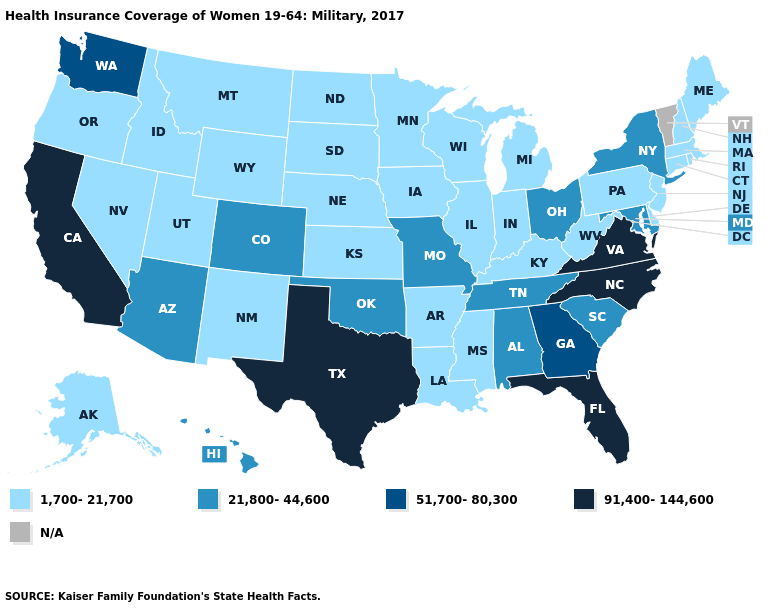Does Arizona have the highest value in the USA?
Be succinct. No. Name the states that have a value in the range 91,400-144,600?
Answer briefly. California, Florida, North Carolina, Texas, Virginia. What is the value of New York?
Be succinct. 21,800-44,600. Among the states that border Mississippi , which have the highest value?
Short answer required. Alabama, Tennessee. Name the states that have a value in the range 21,800-44,600?
Quick response, please. Alabama, Arizona, Colorado, Hawaii, Maryland, Missouri, New York, Ohio, Oklahoma, South Carolina, Tennessee. Which states hav the highest value in the West?
Concise answer only. California. Does Maine have the highest value in the Northeast?
Answer briefly. No. What is the value of Nevada?
Give a very brief answer. 1,700-21,700. Does West Virginia have the highest value in the USA?
Quick response, please. No. Is the legend a continuous bar?
Concise answer only. No. Which states hav the highest value in the MidWest?
Write a very short answer. Missouri, Ohio. Does West Virginia have the lowest value in the South?
Short answer required. Yes. Does Texas have the highest value in the South?
Concise answer only. Yes. 